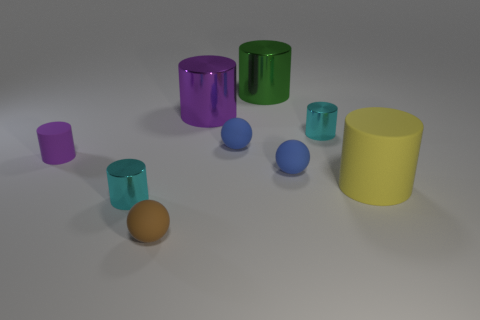Subtract all green cylinders. How many cylinders are left? 5 Subtract 1 cylinders. How many cylinders are left? 5 Subtract all cyan metal cylinders. How many cylinders are left? 4 Subtract all red cylinders. Subtract all brown blocks. How many cylinders are left? 6 Add 1 small shiny objects. How many objects exist? 10 Subtract all spheres. How many objects are left? 6 Add 8 purple matte cubes. How many purple matte cubes exist? 8 Subtract 1 cyan cylinders. How many objects are left? 8 Subtract all green metal cylinders. Subtract all matte cylinders. How many objects are left? 6 Add 3 green objects. How many green objects are left? 4 